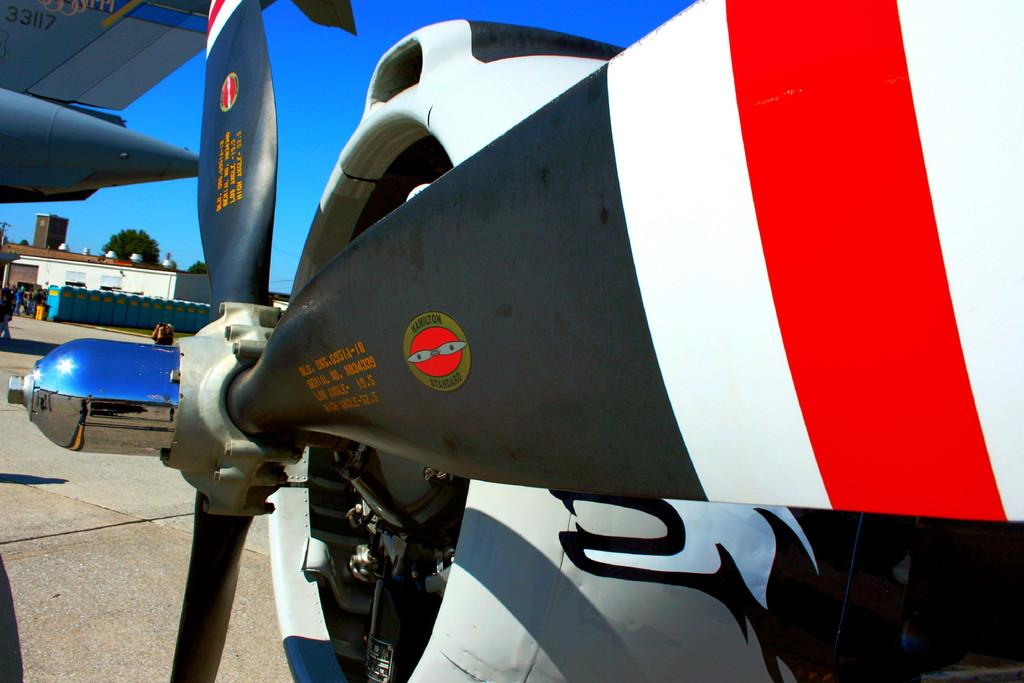<image>
Relay a brief, clear account of the picture shown. The propeller is black and red and white with a sticker that says Hamilton standard 